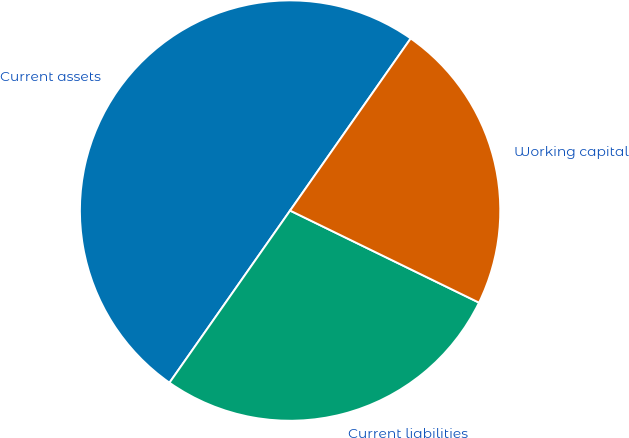Convert chart to OTSL. <chart><loc_0><loc_0><loc_500><loc_500><pie_chart><fcel>Current assets<fcel>Current liabilities<fcel>Working capital<nl><fcel>50.0%<fcel>27.51%<fcel>22.49%<nl></chart> 